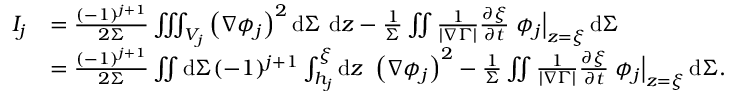Convert formula to latex. <formula><loc_0><loc_0><loc_500><loc_500>\begin{array} { r l } { I _ { j } } & { = \frac { ( - 1 ) ^ { j + 1 } } { 2 \Sigma } \iiint _ { V _ { j } } \left ( \nabla \phi _ { j } \right ) ^ { 2 } d \Sigma d z - \frac { 1 } { \Sigma } \iint \frac { 1 } { | \nabla \Gamma | } \frac { \partial \xi } { \partial t } \phi _ { j } \right | _ { z = \xi } d \Sigma } \\ & { = \frac { ( - 1 ) ^ { j + 1 } } { 2 \Sigma } \iint d \Sigma ( - 1 ) ^ { j + 1 } \int _ { h _ { j } } ^ { \xi } d z \left ( \nabla \phi _ { j } \right ) ^ { 2 } - \frac { 1 } { \Sigma } \iint \frac { 1 } { | \nabla \Gamma | } \frac { \partial \xi } { \partial t } \phi _ { j } \right | _ { z = \xi } d \Sigma . } \end{array}</formula> 